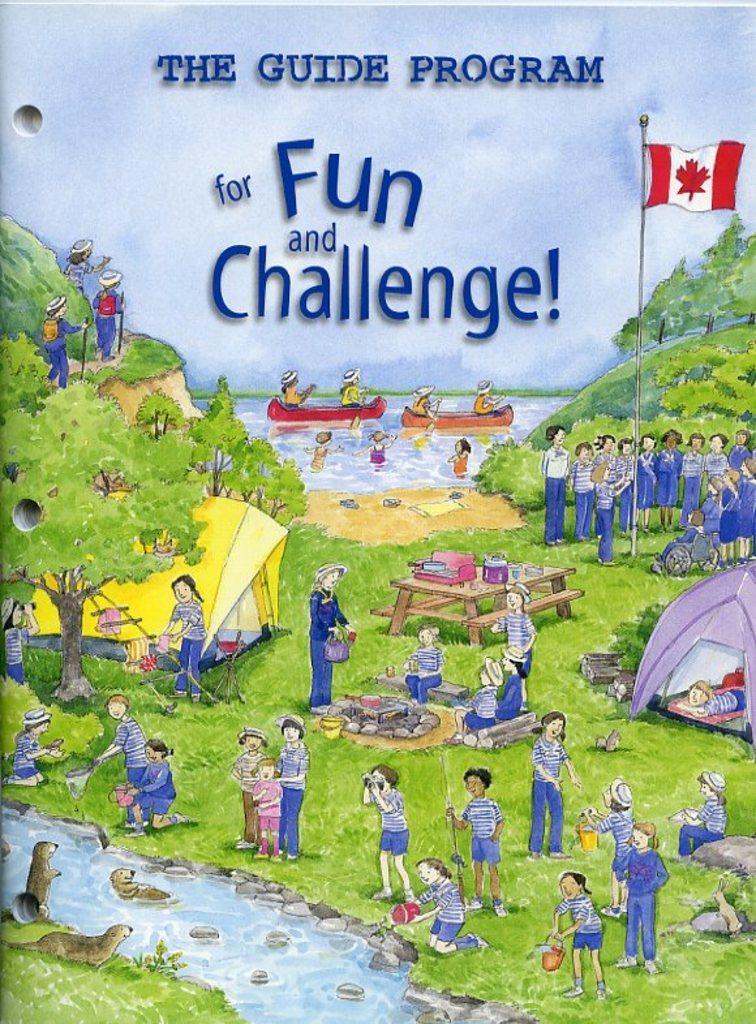Can you describe this image briefly? In this picture we can see people standing near to a flag. In the background we can see water, people and boats. Here on a table we can see objects. These are tent houses and here we can see people. These are animals. 